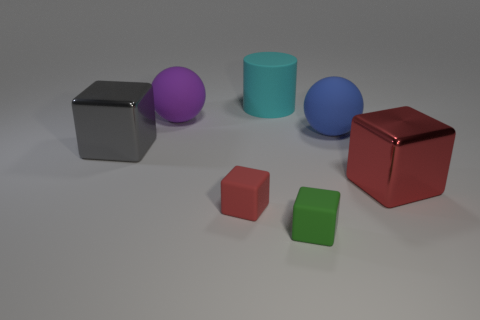What number of other things are the same material as the large purple sphere?
Give a very brief answer. 4. There is another ball that is the same size as the purple matte ball; what is it made of?
Provide a succinct answer. Rubber. There is a large metallic thing behind the large red metallic cube; is its shape the same as the red object that is right of the red matte block?
Make the answer very short. Yes. There is a blue matte object that is the same size as the purple thing; what shape is it?
Your answer should be very brief. Sphere. Is the red block that is to the left of the large cyan matte cylinder made of the same material as the big ball that is right of the large cyan rubber thing?
Give a very brief answer. Yes. Are there any blue things that are behind the large metallic block in front of the large gray metallic thing?
Provide a short and direct response. Yes. What is the color of the big sphere that is the same material as the large purple object?
Offer a terse response. Blue. Is the number of red metallic blocks greater than the number of yellow matte balls?
Provide a succinct answer. Yes. What number of objects are either large blocks in front of the gray metallic block or green balls?
Offer a very short reply. 1. Is there a green matte object that has the same size as the red rubber object?
Give a very brief answer. Yes. 